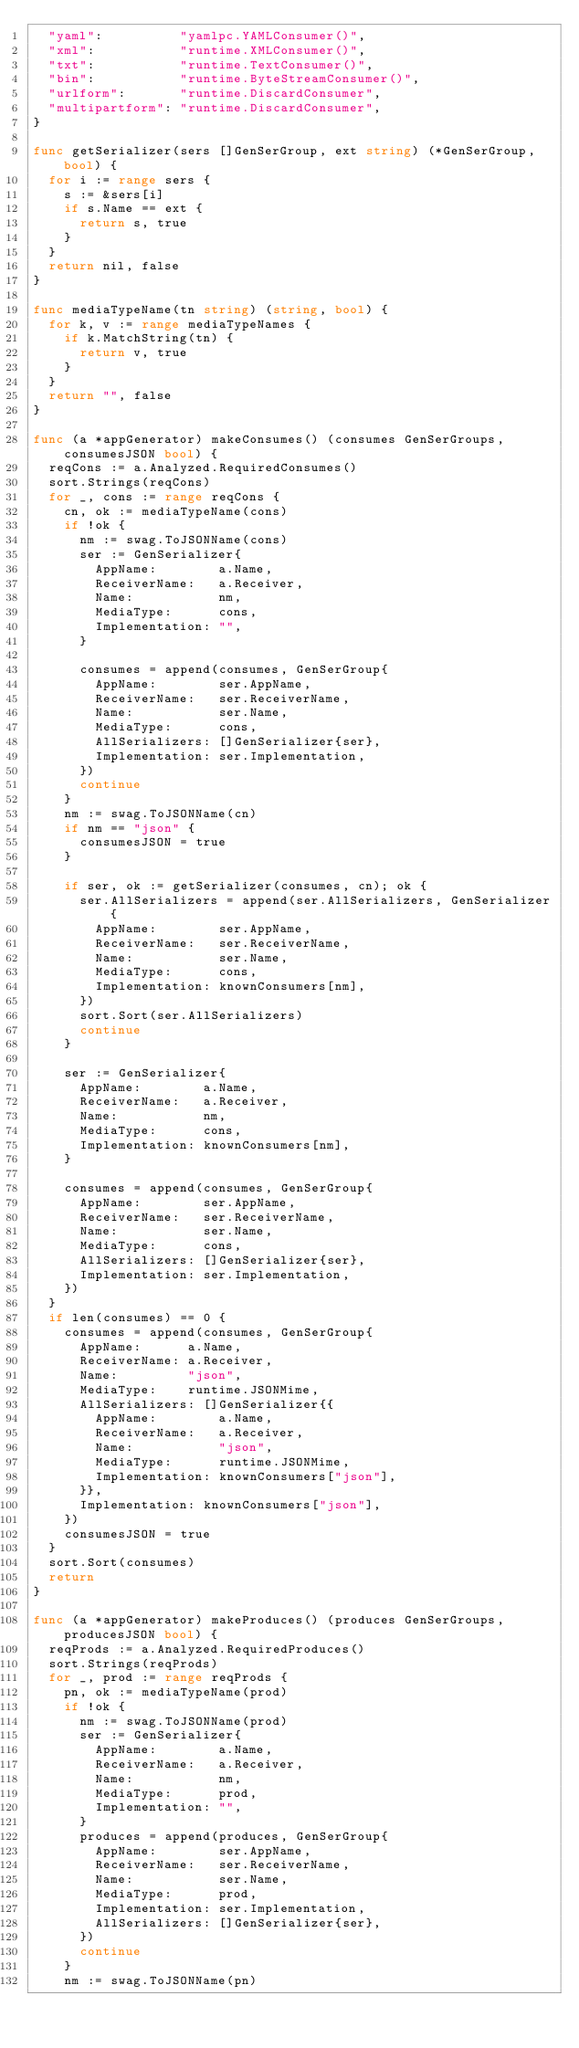Convert code to text. <code><loc_0><loc_0><loc_500><loc_500><_Go_>	"yaml":          "yamlpc.YAMLConsumer()",
	"xml":           "runtime.XMLConsumer()",
	"txt":           "runtime.TextConsumer()",
	"bin":           "runtime.ByteStreamConsumer()",
	"urlform":       "runtime.DiscardConsumer",
	"multipartform": "runtime.DiscardConsumer",
}

func getSerializer(sers []GenSerGroup, ext string) (*GenSerGroup, bool) {
	for i := range sers {
		s := &sers[i]
		if s.Name == ext {
			return s, true
		}
	}
	return nil, false
}

func mediaTypeName(tn string) (string, bool) {
	for k, v := range mediaTypeNames {
		if k.MatchString(tn) {
			return v, true
		}
	}
	return "", false
}

func (a *appGenerator) makeConsumes() (consumes GenSerGroups, consumesJSON bool) {
	reqCons := a.Analyzed.RequiredConsumes()
	sort.Strings(reqCons)
	for _, cons := range reqCons {
		cn, ok := mediaTypeName(cons)
		if !ok {
			nm := swag.ToJSONName(cons)
			ser := GenSerializer{
				AppName:        a.Name,
				ReceiverName:   a.Receiver,
				Name:           nm,
				MediaType:      cons,
				Implementation: "",
			}

			consumes = append(consumes, GenSerGroup{
				AppName:        ser.AppName,
				ReceiverName:   ser.ReceiverName,
				Name:           ser.Name,
				MediaType:      cons,
				AllSerializers: []GenSerializer{ser},
				Implementation: ser.Implementation,
			})
			continue
		}
		nm := swag.ToJSONName(cn)
		if nm == "json" {
			consumesJSON = true
		}

		if ser, ok := getSerializer(consumes, cn); ok {
			ser.AllSerializers = append(ser.AllSerializers, GenSerializer{
				AppName:        ser.AppName,
				ReceiverName:   ser.ReceiverName,
				Name:           ser.Name,
				MediaType:      cons,
				Implementation: knownConsumers[nm],
			})
			sort.Sort(ser.AllSerializers)
			continue
		}

		ser := GenSerializer{
			AppName:        a.Name,
			ReceiverName:   a.Receiver,
			Name:           nm,
			MediaType:      cons,
			Implementation: knownConsumers[nm],
		}

		consumes = append(consumes, GenSerGroup{
			AppName:        ser.AppName,
			ReceiverName:   ser.ReceiverName,
			Name:           ser.Name,
			MediaType:      cons,
			AllSerializers: []GenSerializer{ser},
			Implementation: ser.Implementation,
		})
	}
	if len(consumes) == 0 {
		consumes = append(consumes, GenSerGroup{
			AppName:      a.Name,
			ReceiverName: a.Receiver,
			Name:         "json",
			MediaType:    runtime.JSONMime,
			AllSerializers: []GenSerializer{{
				AppName:        a.Name,
				ReceiverName:   a.Receiver,
				Name:           "json",
				MediaType:      runtime.JSONMime,
				Implementation: knownConsumers["json"],
			}},
			Implementation: knownConsumers["json"],
		})
		consumesJSON = true
	}
	sort.Sort(consumes)
	return
}

func (a *appGenerator) makeProduces() (produces GenSerGroups, producesJSON bool) {
	reqProds := a.Analyzed.RequiredProduces()
	sort.Strings(reqProds)
	for _, prod := range reqProds {
		pn, ok := mediaTypeName(prod)
		if !ok {
			nm := swag.ToJSONName(prod)
			ser := GenSerializer{
				AppName:        a.Name,
				ReceiverName:   a.Receiver,
				Name:           nm,
				MediaType:      prod,
				Implementation: "",
			}
			produces = append(produces, GenSerGroup{
				AppName:        ser.AppName,
				ReceiverName:   ser.ReceiverName,
				Name:           ser.Name,
				MediaType:      prod,
				Implementation: ser.Implementation,
				AllSerializers: []GenSerializer{ser},
			})
			continue
		}
		nm := swag.ToJSONName(pn)</code> 